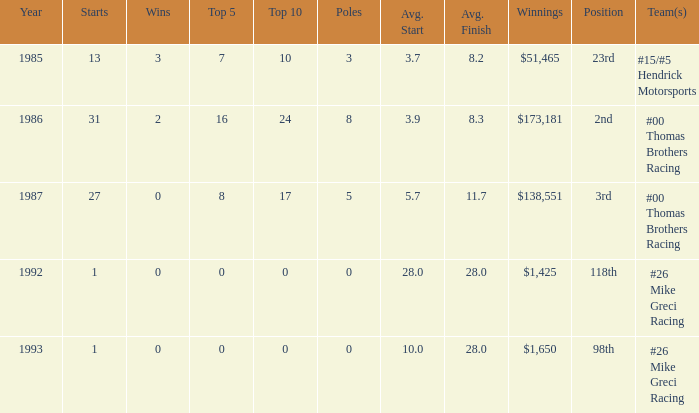What team was Bodine in when he had an average finish of 8.3? #00 Thomas Brothers Racing. 